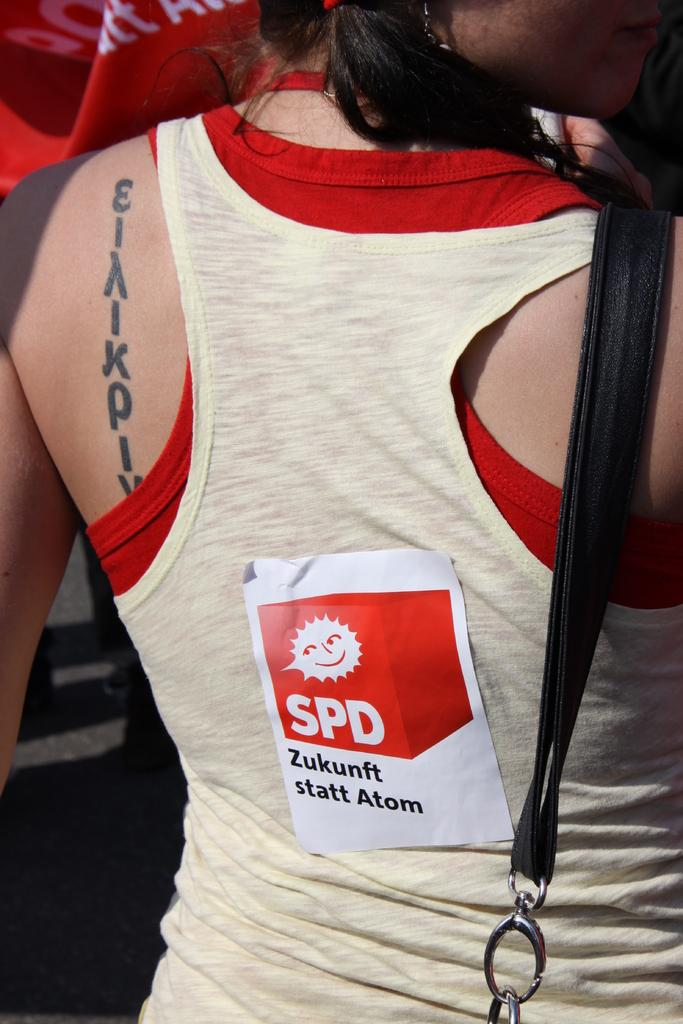<image>
Write a terse but informative summary of the picture. A woman with a tattoo has a sticker on her back that says SPD. 